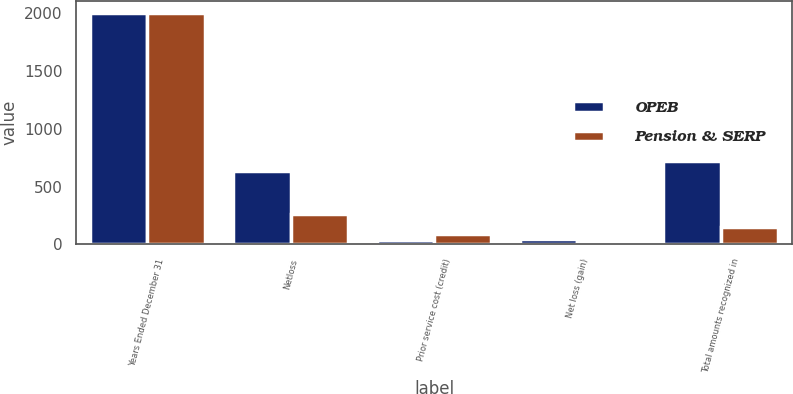Convert chart. <chart><loc_0><loc_0><loc_500><loc_500><stacked_bar_chart><ecel><fcel>Years Ended December 31<fcel>Netloss<fcel>Prior service cost (credit)<fcel>Net loss (gain)<fcel>Total amounts recognized in<nl><fcel>OPEB<fcel>2007<fcel>636<fcel>39<fcel>46<fcel>724<nl><fcel>Pension & SERP<fcel>2007<fcel>265<fcel>89<fcel>22<fcel>151<nl></chart> 